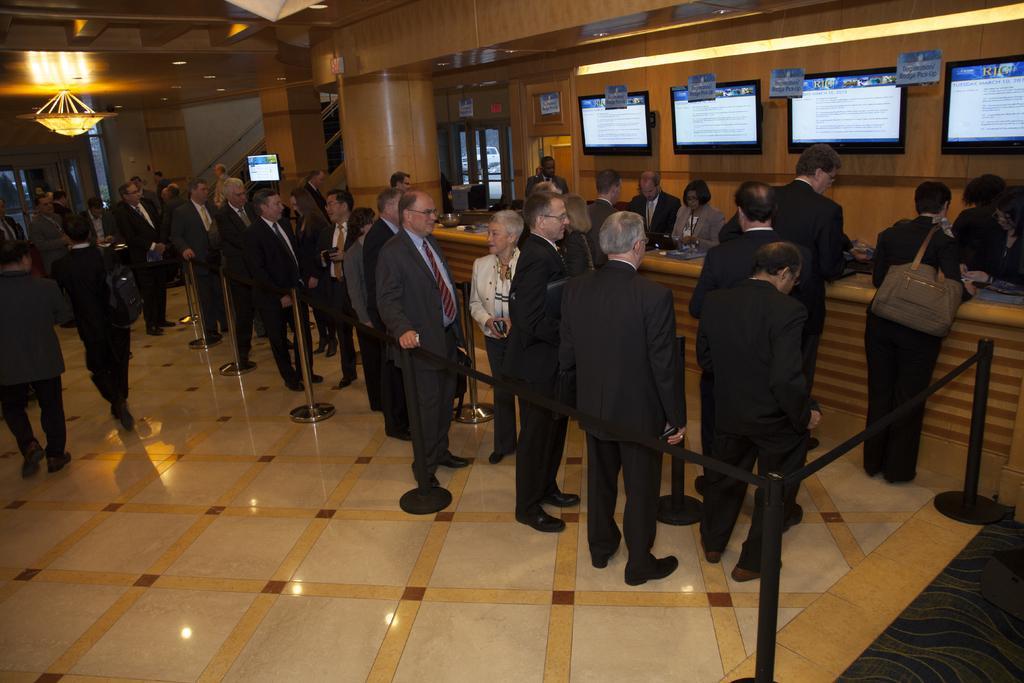Please provide a concise description of this image. In this image there are group of people standing, there are rope barriers, televisions and a chandelier. 